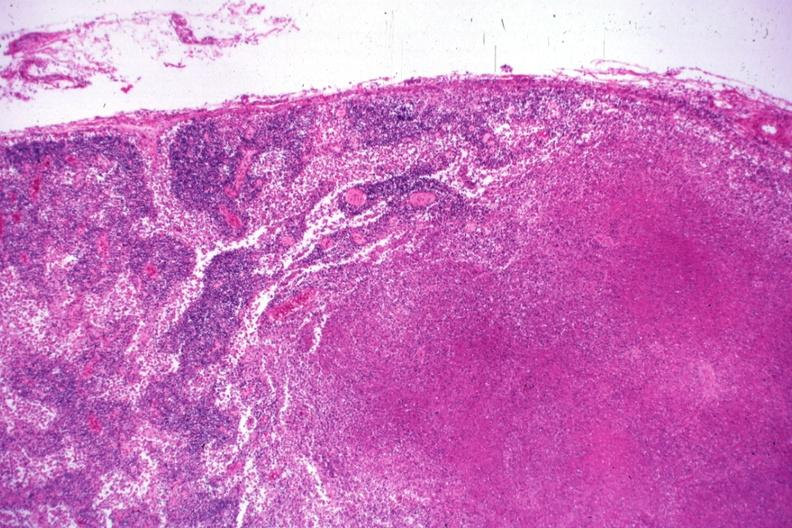s fibrotic lesion present?
Answer the question using a single word or phrase. No 